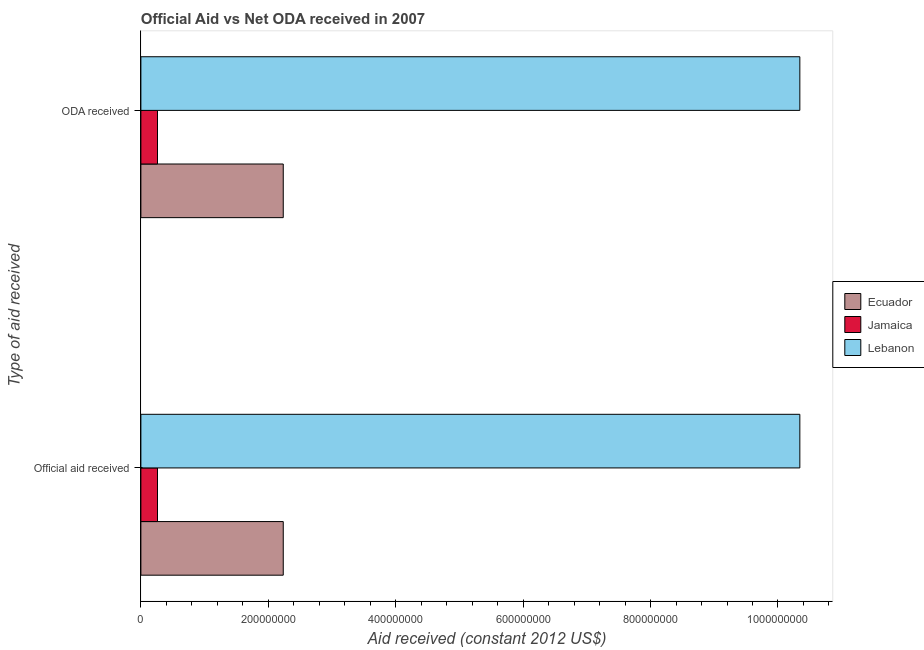How many different coloured bars are there?
Provide a short and direct response. 3. How many bars are there on the 1st tick from the bottom?
Offer a terse response. 3. What is the label of the 2nd group of bars from the top?
Ensure brevity in your answer.  Official aid received. What is the oda received in Jamaica?
Make the answer very short. 2.61e+07. Across all countries, what is the maximum official aid received?
Provide a succinct answer. 1.03e+09. Across all countries, what is the minimum oda received?
Ensure brevity in your answer.  2.61e+07. In which country was the oda received maximum?
Your response must be concise. Lebanon. In which country was the official aid received minimum?
Give a very brief answer. Jamaica. What is the total oda received in the graph?
Make the answer very short. 1.28e+09. What is the difference between the official aid received in Lebanon and that in Ecuador?
Make the answer very short. 8.11e+08. What is the difference between the official aid received in Lebanon and the oda received in Jamaica?
Make the answer very short. 1.01e+09. What is the average official aid received per country?
Ensure brevity in your answer.  4.28e+08. What is the difference between the official aid received and oda received in Ecuador?
Make the answer very short. 0. What is the ratio of the oda received in Jamaica to that in Ecuador?
Your answer should be compact. 0.12. Is the official aid received in Lebanon less than that in Ecuador?
Offer a very short reply. No. In how many countries, is the official aid received greater than the average official aid received taken over all countries?
Your response must be concise. 1. What does the 1st bar from the top in ODA received represents?
Your answer should be compact. Lebanon. What does the 1st bar from the bottom in Official aid received represents?
Your response must be concise. Ecuador. How many bars are there?
Ensure brevity in your answer.  6. What is the difference between two consecutive major ticks on the X-axis?
Provide a succinct answer. 2.00e+08. Are the values on the major ticks of X-axis written in scientific E-notation?
Ensure brevity in your answer.  No. Does the graph contain any zero values?
Your answer should be very brief. No. Does the graph contain grids?
Offer a very short reply. No. How are the legend labels stacked?
Make the answer very short. Vertical. What is the title of the graph?
Your answer should be compact. Official Aid vs Net ODA received in 2007 . What is the label or title of the X-axis?
Give a very brief answer. Aid received (constant 2012 US$). What is the label or title of the Y-axis?
Your answer should be very brief. Type of aid received. What is the Aid received (constant 2012 US$) of Ecuador in Official aid received?
Give a very brief answer. 2.23e+08. What is the Aid received (constant 2012 US$) of Jamaica in Official aid received?
Ensure brevity in your answer.  2.61e+07. What is the Aid received (constant 2012 US$) of Lebanon in Official aid received?
Your answer should be very brief. 1.03e+09. What is the Aid received (constant 2012 US$) in Ecuador in ODA received?
Make the answer very short. 2.23e+08. What is the Aid received (constant 2012 US$) in Jamaica in ODA received?
Your response must be concise. 2.61e+07. What is the Aid received (constant 2012 US$) of Lebanon in ODA received?
Offer a very short reply. 1.03e+09. Across all Type of aid received, what is the maximum Aid received (constant 2012 US$) of Ecuador?
Provide a short and direct response. 2.23e+08. Across all Type of aid received, what is the maximum Aid received (constant 2012 US$) of Jamaica?
Keep it short and to the point. 2.61e+07. Across all Type of aid received, what is the maximum Aid received (constant 2012 US$) of Lebanon?
Ensure brevity in your answer.  1.03e+09. Across all Type of aid received, what is the minimum Aid received (constant 2012 US$) in Ecuador?
Offer a very short reply. 2.23e+08. Across all Type of aid received, what is the minimum Aid received (constant 2012 US$) in Jamaica?
Keep it short and to the point. 2.61e+07. Across all Type of aid received, what is the minimum Aid received (constant 2012 US$) of Lebanon?
Keep it short and to the point. 1.03e+09. What is the total Aid received (constant 2012 US$) in Ecuador in the graph?
Make the answer very short. 4.47e+08. What is the total Aid received (constant 2012 US$) in Jamaica in the graph?
Provide a short and direct response. 5.21e+07. What is the total Aid received (constant 2012 US$) in Lebanon in the graph?
Provide a short and direct response. 2.07e+09. What is the difference between the Aid received (constant 2012 US$) in Ecuador in Official aid received and that in ODA received?
Your response must be concise. 0. What is the difference between the Aid received (constant 2012 US$) of Jamaica in Official aid received and that in ODA received?
Offer a very short reply. 0. What is the difference between the Aid received (constant 2012 US$) of Ecuador in Official aid received and the Aid received (constant 2012 US$) of Jamaica in ODA received?
Give a very brief answer. 1.97e+08. What is the difference between the Aid received (constant 2012 US$) of Ecuador in Official aid received and the Aid received (constant 2012 US$) of Lebanon in ODA received?
Provide a short and direct response. -8.11e+08. What is the difference between the Aid received (constant 2012 US$) in Jamaica in Official aid received and the Aid received (constant 2012 US$) in Lebanon in ODA received?
Your answer should be compact. -1.01e+09. What is the average Aid received (constant 2012 US$) in Ecuador per Type of aid received?
Your answer should be very brief. 2.23e+08. What is the average Aid received (constant 2012 US$) in Jamaica per Type of aid received?
Your answer should be very brief. 2.61e+07. What is the average Aid received (constant 2012 US$) in Lebanon per Type of aid received?
Your response must be concise. 1.03e+09. What is the difference between the Aid received (constant 2012 US$) of Ecuador and Aid received (constant 2012 US$) of Jamaica in Official aid received?
Offer a very short reply. 1.97e+08. What is the difference between the Aid received (constant 2012 US$) of Ecuador and Aid received (constant 2012 US$) of Lebanon in Official aid received?
Your answer should be very brief. -8.11e+08. What is the difference between the Aid received (constant 2012 US$) of Jamaica and Aid received (constant 2012 US$) of Lebanon in Official aid received?
Your answer should be compact. -1.01e+09. What is the difference between the Aid received (constant 2012 US$) in Ecuador and Aid received (constant 2012 US$) in Jamaica in ODA received?
Give a very brief answer. 1.97e+08. What is the difference between the Aid received (constant 2012 US$) in Ecuador and Aid received (constant 2012 US$) in Lebanon in ODA received?
Your answer should be compact. -8.11e+08. What is the difference between the Aid received (constant 2012 US$) of Jamaica and Aid received (constant 2012 US$) of Lebanon in ODA received?
Your response must be concise. -1.01e+09. What is the ratio of the Aid received (constant 2012 US$) of Jamaica in Official aid received to that in ODA received?
Offer a terse response. 1. What is the difference between the highest and the second highest Aid received (constant 2012 US$) in Jamaica?
Provide a succinct answer. 0. What is the difference between the highest and the lowest Aid received (constant 2012 US$) in Ecuador?
Your answer should be very brief. 0. What is the difference between the highest and the lowest Aid received (constant 2012 US$) of Jamaica?
Give a very brief answer. 0. What is the difference between the highest and the lowest Aid received (constant 2012 US$) of Lebanon?
Provide a succinct answer. 0. 